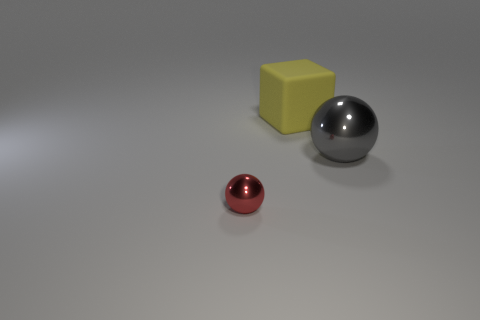What is the size of the thing that is both in front of the rubber block and behind the small red shiny sphere?
Your answer should be very brief. Large. Are there any other large things that have the same color as the large rubber object?
Give a very brief answer. No. What is the color of the thing on the right side of the big object that is on the left side of the gray shiny thing?
Offer a terse response. Gray. Is the number of metallic things that are to the right of the gray metal thing less than the number of small red metal things to the right of the yellow rubber cube?
Make the answer very short. No. Is the size of the red thing the same as the gray sphere?
Offer a very short reply. No. What shape is the thing that is in front of the large rubber thing and on the left side of the large gray thing?
Offer a terse response. Sphere. What number of large gray objects are the same material as the gray ball?
Your answer should be compact. 0. There is a shiny thing behind the tiny metallic thing; how many blocks are left of it?
Your answer should be compact. 1. There is a yellow object on the right side of the metallic object in front of the large thing that is on the right side of the yellow cube; what shape is it?
Your answer should be very brief. Cube. What number of things are either big gray blocks or small metal balls?
Keep it short and to the point. 1. 